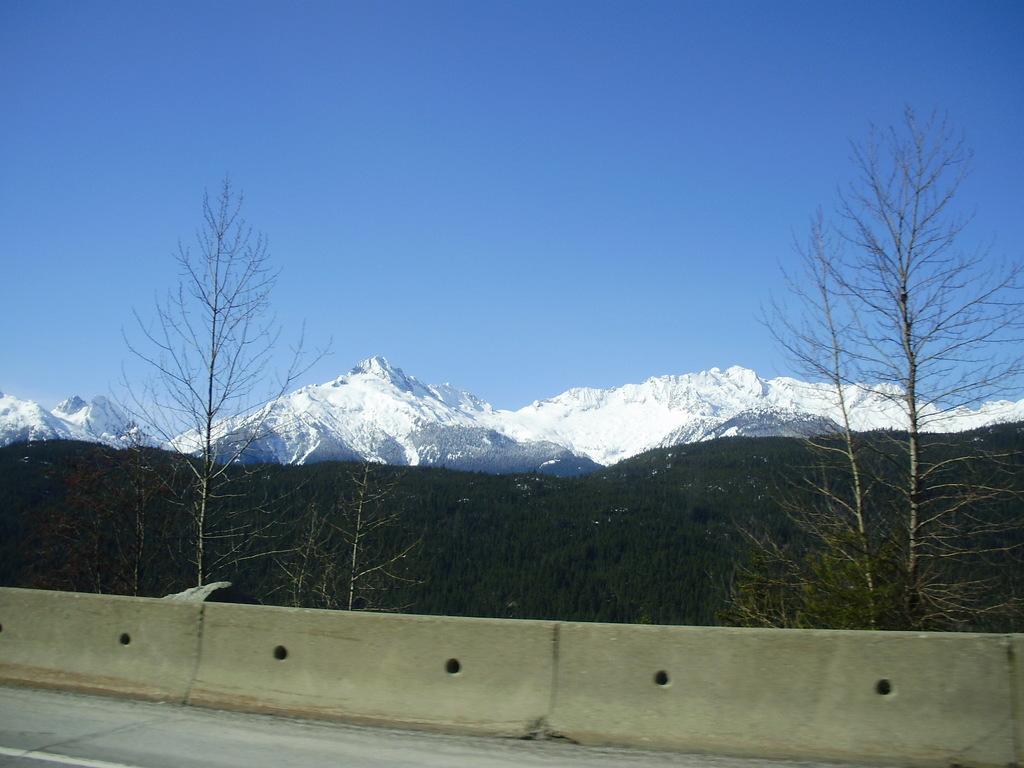Can you describe this image briefly? On the bottom we can see the concrete wall near to the road. In the background we can see snow mountain and trees. On the top there is a sky. 